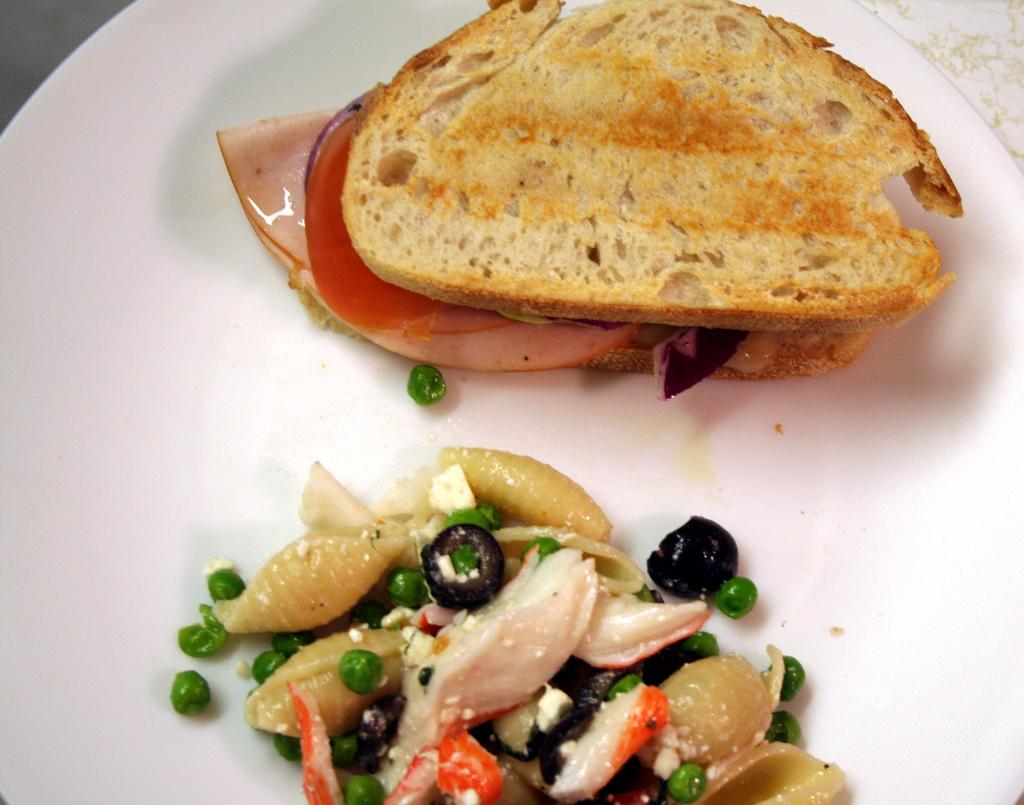What type of food is featured in the image? There is a salad and a toast in the image. What is on top of the toast? The toast has bacon on it. What type of yam is being used for teaching in the image? There is no yam or teaching activity present in the image. What type of beef is being served with the salad in the image? There is no beef present in the image; the toast has bacon on it, and the salad is not mentioned as having any specific ingredients. 